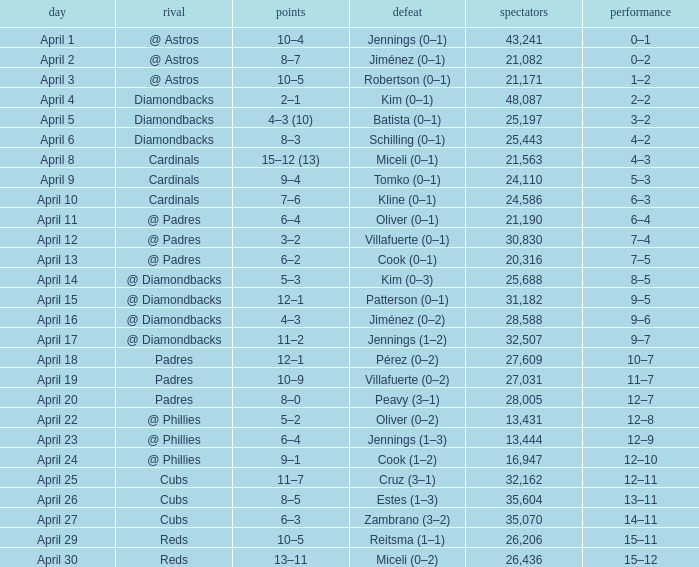What is the team's record on april 23? 12–9. 